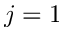Convert formula to latex. <formula><loc_0><loc_0><loc_500><loc_500>j = 1</formula> 